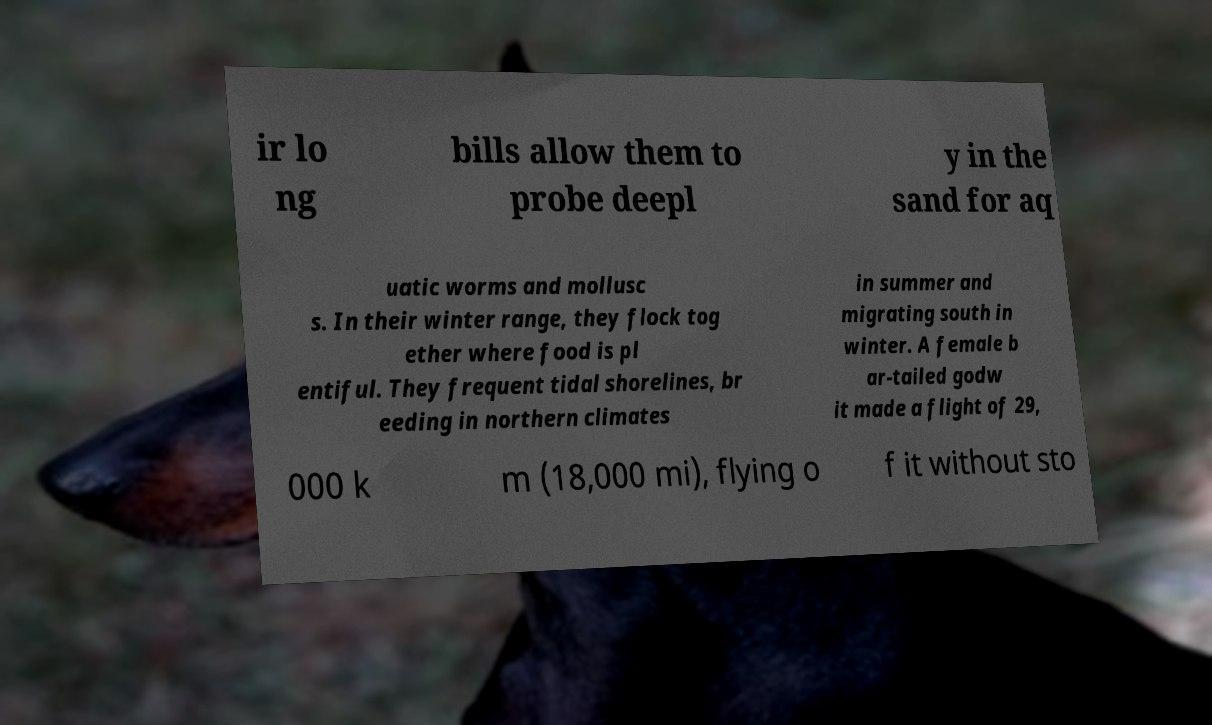Can you accurately transcribe the text from the provided image for me? ir lo ng bills allow them to probe deepl y in the sand for aq uatic worms and mollusc s. In their winter range, they flock tog ether where food is pl entiful. They frequent tidal shorelines, br eeding in northern climates in summer and migrating south in winter. A female b ar-tailed godw it made a flight of 29, 000 k m (18,000 mi), flying o f it without sto 